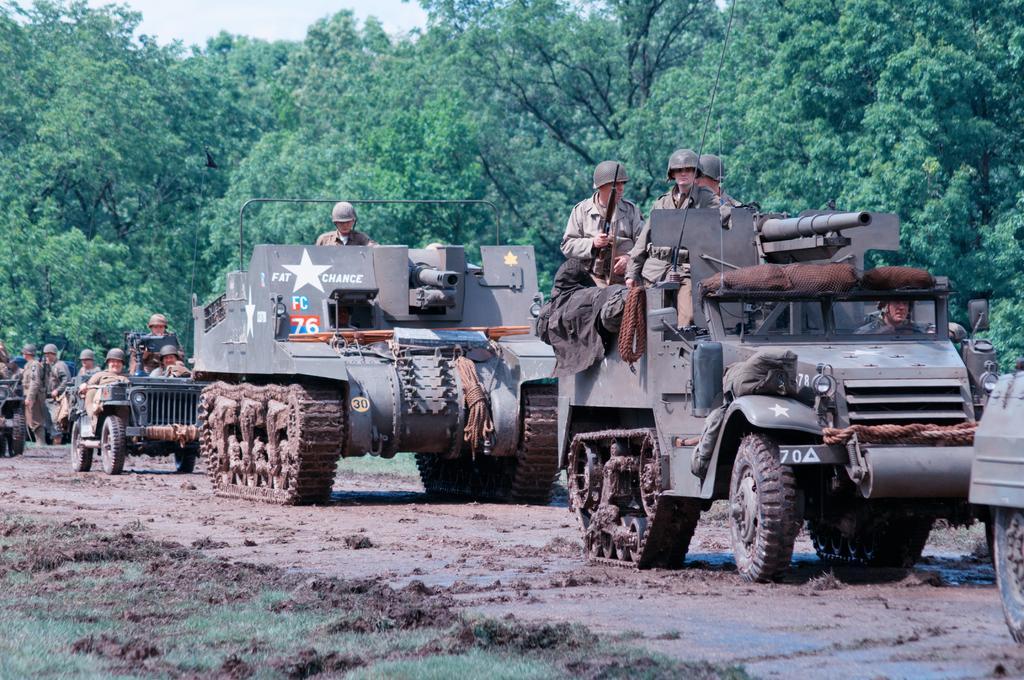In one or two sentences, can you explain what this image depicts? This image is taken outdoors. At the bottom of the image there is a ground with grass on it. In the background there are many trees with stems, branches and green leaves. At the top of the image there is the sky with clouds. In the middle of the image many vehicles are moving on the ground and a few people are sitting in the vehicles and they are holding guns in their hands. A few people are standing on the ground. 